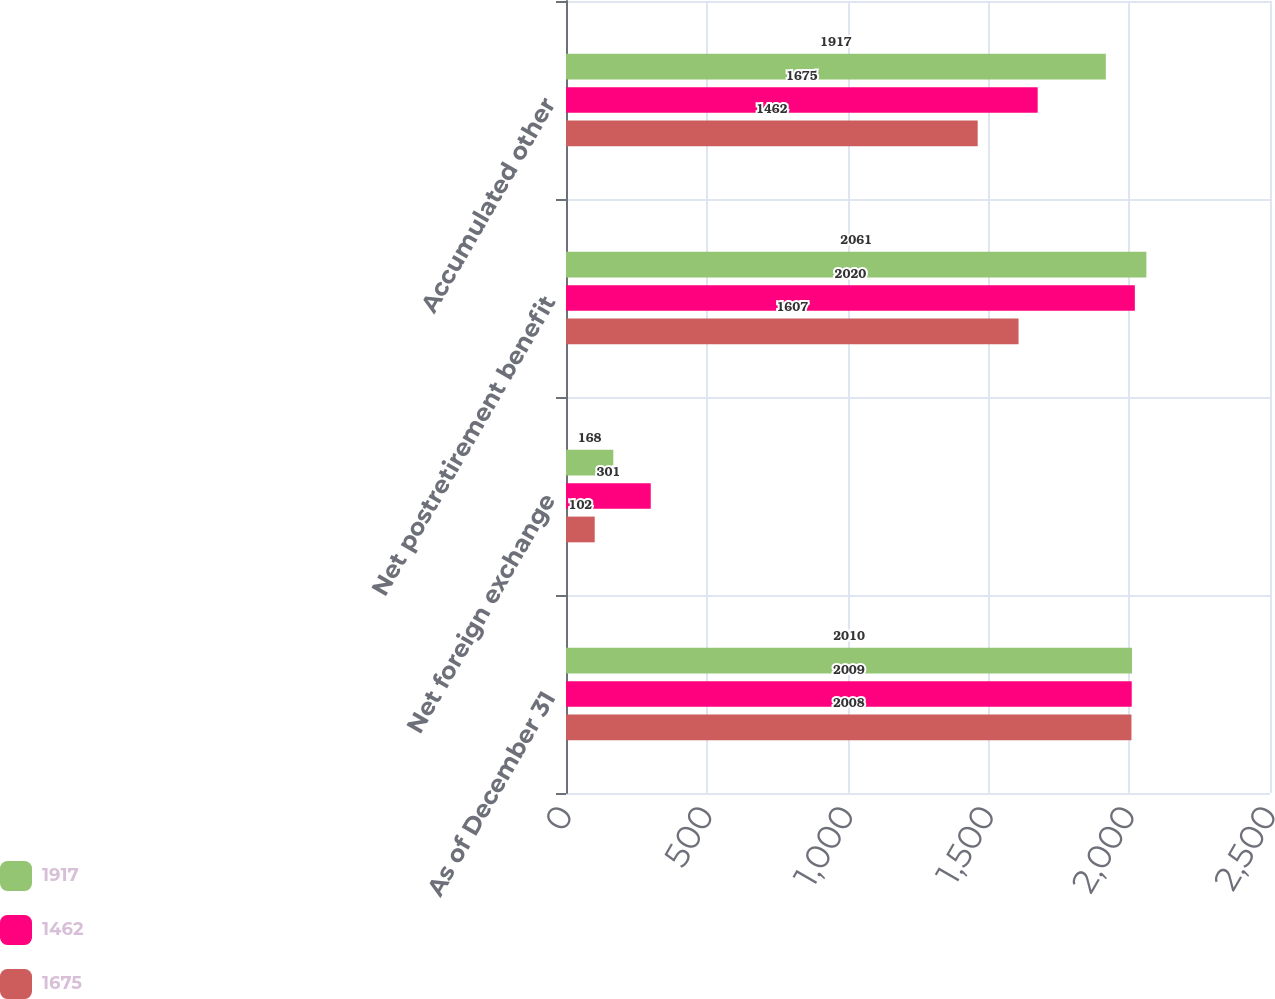Convert chart. <chart><loc_0><loc_0><loc_500><loc_500><stacked_bar_chart><ecel><fcel>As of December 31<fcel>Net foreign exchange<fcel>Net postretirement benefit<fcel>Accumulated other<nl><fcel>1917<fcel>2010<fcel>168<fcel>2061<fcel>1917<nl><fcel>1462<fcel>2009<fcel>301<fcel>2020<fcel>1675<nl><fcel>1675<fcel>2008<fcel>102<fcel>1607<fcel>1462<nl></chart> 